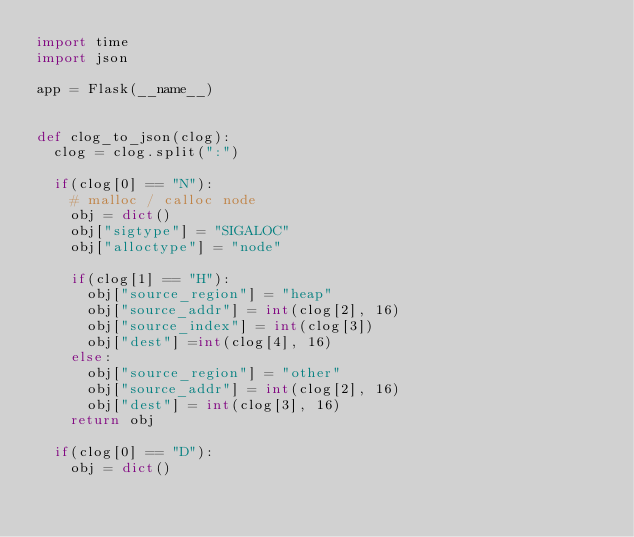<code> <loc_0><loc_0><loc_500><loc_500><_Python_>import time
import json

app = Flask(__name__)


def clog_to_json(clog):
	clog = clog.split(":")

	if(clog[0] == "N"):
		# malloc / calloc node
		obj = dict()
		obj["sigtype"] = "SIGALOC"
		obj["alloctype"] = "node"

		if(clog[1] == "H"):
			obj["source_region"] = "heap"
			obj["source_addr"] = int(clog[2], 16)
			obj["source_index"] = int(clog[3])
			obj["dest"] =int(clog[4], 16)
		else:
			obj["source_region"] = "other"
			obj["source_addr"] = int(clog[2], 16)
			obj["dest"] = int(clog[3], 16)
		return obj

	if(clog[0] == "D"):
		obj = dict()</code> 